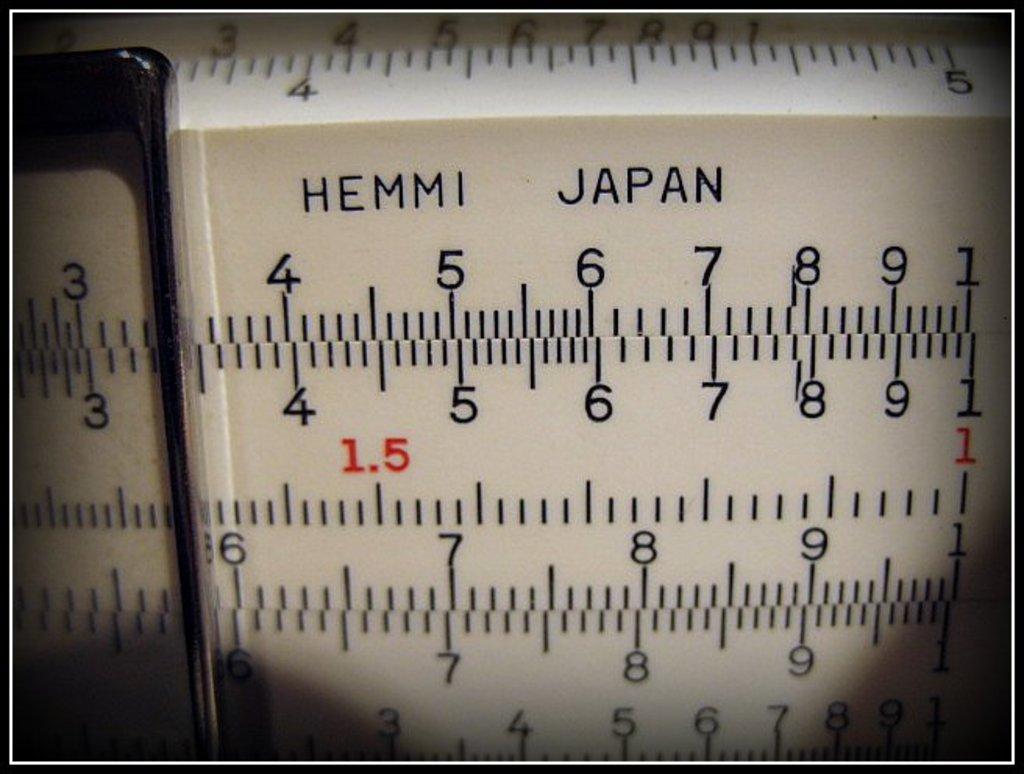Where is this gauge made?
Make the answer very short. Japan. 